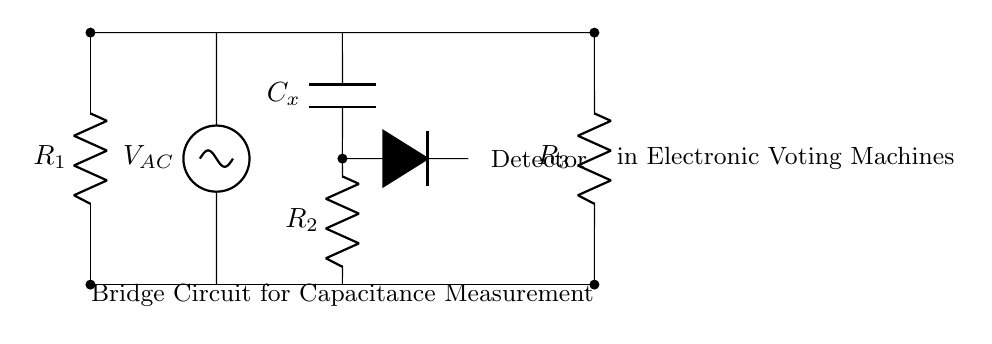What type of circuit is depicted in the diagram? The diagram represents a bridge circuit used for measuring capacitance. This is indicated by the arrangement of resistors and capacitor, typical of AC bridge configurations.
Answer: Bridge circuit What is the function of the component labeled C_x? The component labeled C_x is a capacitor used for the measurement of capacitance in the circuit. It is placed in the arms of the bridge to balance the circuit.
Answer: Capacitor How many resistors are present in the circuit? There are three resistors total: R1, R2, and R3 as depicted in the diagram in the left and right arms of the bridge circuit.
Answer: Three What is the role of the detector in this circuit? The detector functions to identify the balance in the bridge circuit, indicating when the impedance conditions satisfy the measurement criteria for capacitance.
Answer: Measurement What happens if R1 is equal to R3? If R1 equals R3, the bridge will balance when the ratio of R2 and C_x satisfies the conditions for capacitance measurement, indicating no potential difference across the detector.
Answer: Balance achieved What is the significance of the AC voltage source in this circuit? The AC voltage source provides the varying current necessary for the operation of the bridge, allowing for the detection of changes in the circuit due to capacitance.
Answer: Supplies AC voltage What connections indicate the circuit is a capacitive voltage divider? The arrangement and interplay between R2 and C_x show that this part forms a capacitive voltage divider, where changes in capacitance affect the voltage across the detector.
Answer: R2 and C_x connection 